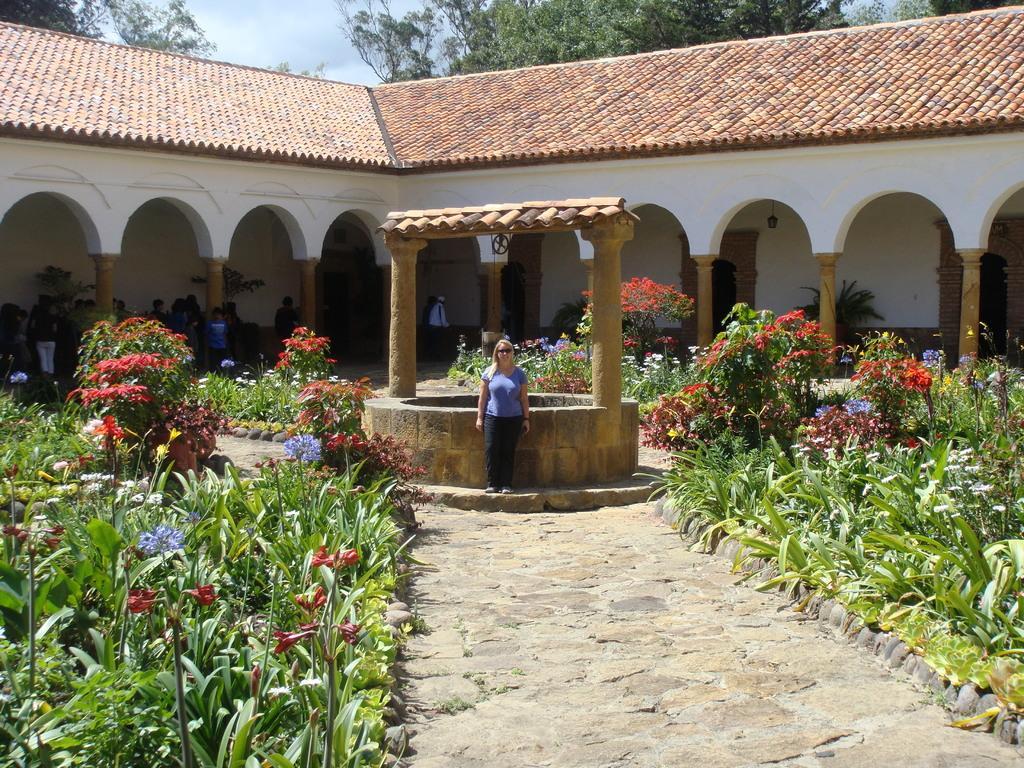Describe this image in one or two sentences. In this image we can see a woman wearing glasses and standing. Behind the woman we can see the well. Image also consists of a house and many plants. We can also see the trees. Sky is also visible. We can also see the path and the stones. 